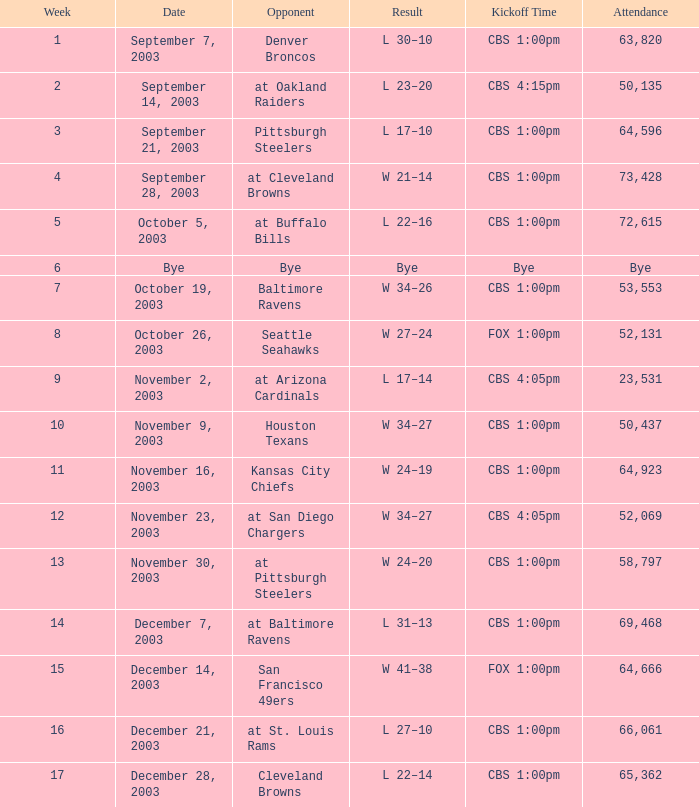What was the result of the game played on November 23, 2003? W 34–27. Write the full table. {'header': ['Week', 'Date', 'Opponent', 'Result', 'Kickoff Time', 'Attendance'], 'rows': [['1', 'September 7, 2003', 'Denver Broncos', 'L 30–10', 'CBS 1:00pm', '63,820'], ['2', 'September 14, 2003', 'at Oakland Raiders', 'L 23–20', 'CBS 4:15pm', '50,135'], ['3', 'September 21, 2003', 'Pittsburgh Steelers', 'L 17–10', 'CBS 1:00pm', '64,596'], ['4', 'September 28, 2003', 'at Cleveland Browns', 'W 21–14', 'CBS 1:00pm', '73,428'], ['5', 'October 5, 2003', 'at Buffalo Bills', 'L 22–16', 'CBS 1:00pm', '72,615'], ['6', 'Bye', 'Bye', 'Bye', 'Bye', 'Bye'], ['7', 'October 19, 2003', 'Baltimore Ravens', 'W 34–26', 'CBS 1:00pm', '53,553'], ['8', 'October 26, 2003', 'Seattle Seahawks', 'W 27–24', 'FOX 1:00pm', '52,131'], ['9', 'November 2, 2003', 'at Arizona Cardinals', 'L 17–14', 'CBS 4:05pm', '23,531'], ['10', 'November 9, 2003', 'Houston Texans', 'W 34–27', 'CBS 1:00pm', '50,437'], ['11', 'November 16, 2003', 'Kansas City Chiefs', 'W 24–19', 'CBS 1:00pm', '64,923'], ['12', 'November 23, 2003', 'at San Diego Chargers', 'W 34–27', 'CBS 4:05pm', '52,069'], ['13', 'November 30, 2003', 'at Pittsburgh Steelers', 'W 24–20', 'CBS 1:00pm', '58,797'], ['14', 'December 7, 2003', 'at Baltimore Ravens', 'L 31–13', 'CBS 1:00pm', '69,468'], ['15', 'December 14, 2003', 'San Francisco 49ers', 'W 41–38', 'FOX 1:00pm', '64,666'], ['16', 'December 21, 2003', 'at St. Louis Rams', 'L 27–10', 'CBS 1:00pm', '66,061'], ['17', 'December 28, 2003', 'Cleveland Browns', 'L 22–14', 'CBS 1:00pm', '65,362']]} 